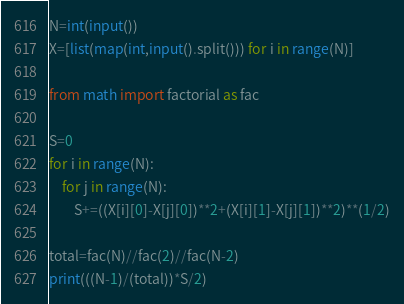Convert code to text. <code><loc_0><loc_0><loc_500><loc_500><_Python_>N=int(input())
X=[list(map(int,input().split())) for i in range(N)]

from math import factorial as fac

S=0
for i in range(N):
    for j in range(N):
        S+=((X[i][0]-X[j][0])**2+(X[i][1]-X[j][1])**2)**(1/2)

total=fac(N)//fac(2)//fac(N-2)
print(((N-1)/(total))*S/2)</code> 